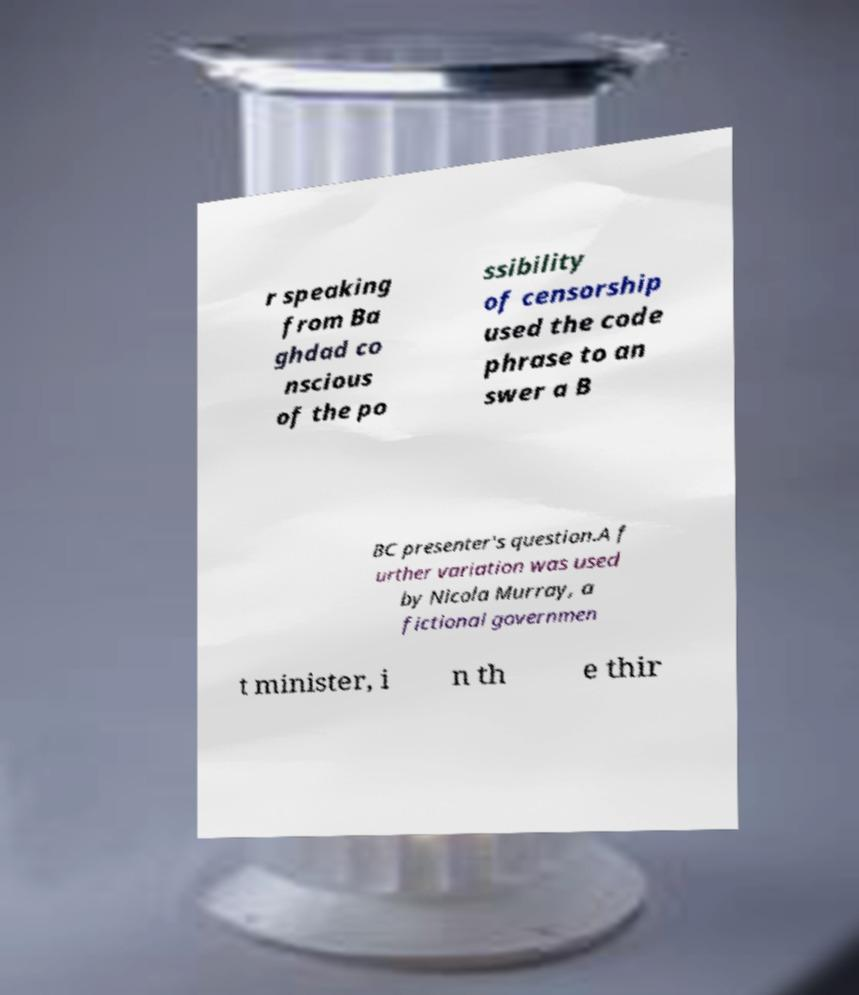There's text embedded in this image that I need extracted. Can you transcribe it verbatim? r speaking from Ba ghdad co nscious of the po ssibility of censorship used the code phrase to an swer a B BC presenter's question.A f urther variation was used by Nicola Murray, a fictional governmen t minister, i n th e thir 